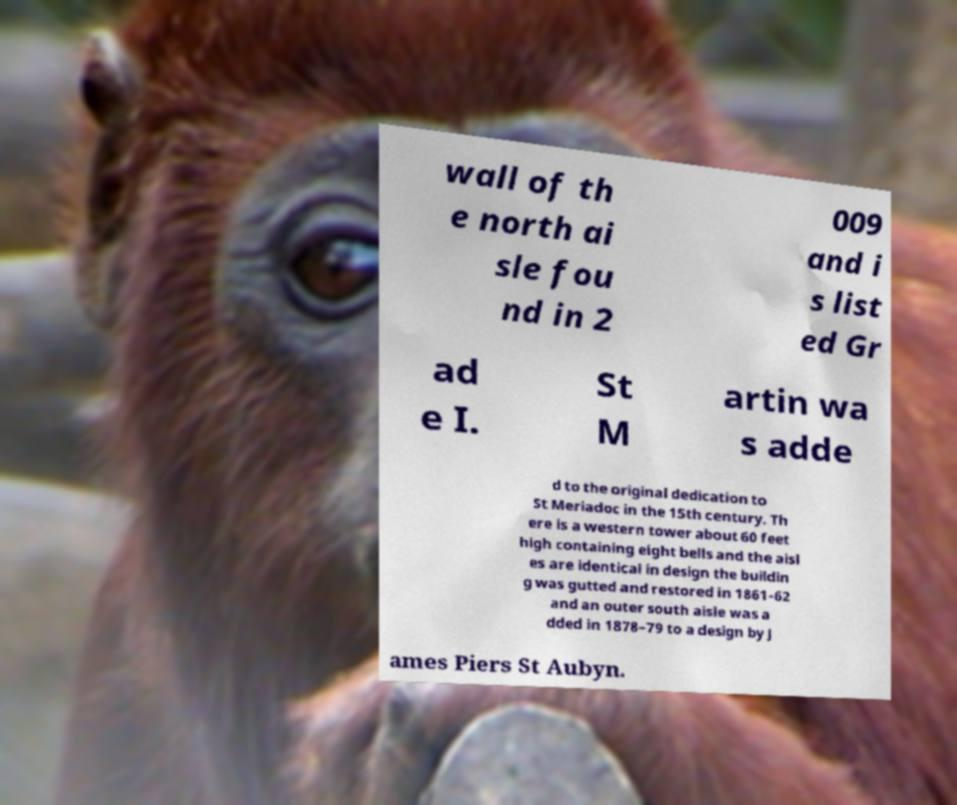There's text embedded in this image that I need extracted. Can you transcribe it verbatim? wall of th e north ai sle fou nd in 2 009 and i s list ed Gr ad e I. St M artin wa s adde d to the original dedication to St Meriadoc in the 15th century. Th ere is a western tower about 60 feet high containing eight bells and the aisl es are identical in design the buildin g was gutted and restored in 1861-62 and an outer south aisle was a dded in 1878–79 to a design by J ames Piers St Aubyn. 